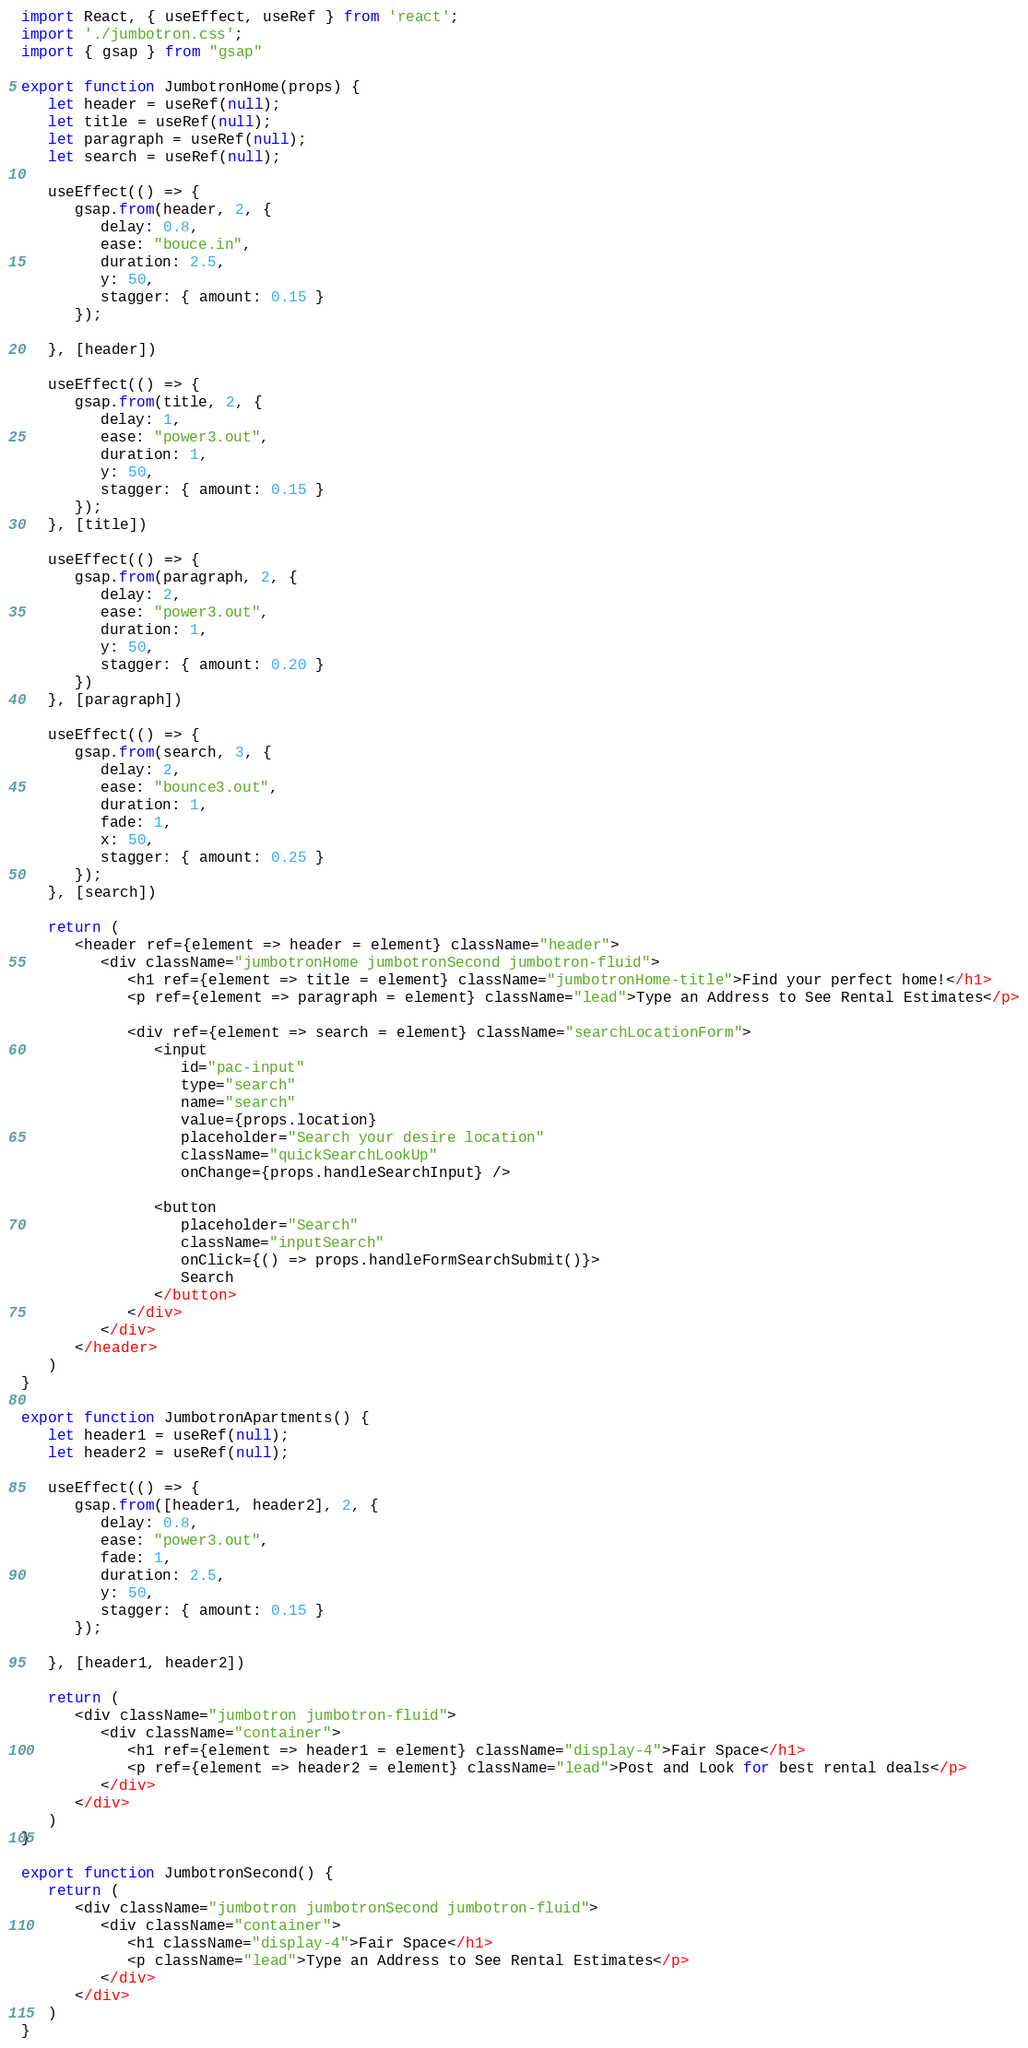<code> <loc_0><loc_0><loc_500><loc_500><_JavaScript_>import React, { useEffect, useRef } from 'react';
import './jumbotron.css';
import { gsap } from "gsap"

export function JumbotronHome(props) {
   let header = useRef(null);
   let title = useRef(null);
   let paragraph = useRef(null);
   let search = useRef(null);

   useEffect(() => {
      gsap.from(header, 2, {
         delay: 0.8,
         ease: "bouce.in",
         duration: 2.5,
         y: 50,
         stagger: { amount: 0.15 }
      });

   }, [header])

   useEffect(() => {
      gsap.from(title, 2, {
         delay: 1,
         ease: "power3.out",
         duration: 1,
         y: 50,
         stagger: { amount: 0.15 }
      });
   }, [title])

   useEffect(() => {
      gsap.from(paragraph, 2, {
         delay: 2,
         ease: "power3.out",
         duration: 1,
         y: 50,
         stagger: { amount: 0.20 }
      })
   }, [paragraph])

   useEffect(() => {
      gsap.from(search, 3, {
         delay: 2,
         ease: "bounce3.out",
         duration: 1,
         fade: 1,
         x: 50,
         stagger: { amount: 0.25 }
      });
   }, [search])

   return (
      <header ref={element => header = element} className="header">
         <div className="jumbotronHome jumbotronSecond jumbotron-fluid">
            <h1 ref={element => title = element} className="jumbotronHome-title">Find your perfect home!</h1>
            <p ref={element => paragraph = element} className="lead">Type an Address to See Rental Estimates</p>

            <div ref={element => search = element} className="searchLocationForm">
               <input
                  id="pac-input"
                  type="search"
                  name="search"
                  value={props.location}
                  placeholder="Search your desire location"
                  className="quickSearchLookUp"
                  onChange={props.handleSearchInput} />

               <button
                  placeholder="Search"
                  className="inputSearch"
                  onClick={() => props.handleFormSearchSubmit()}>
                  Search
               </button>
            </div>
         </div>
      </header>
   )
}

export function JumbotronApartments() {
   let header1 = useRef(null);
   let header2 = useRef(null);

   useEffect(() => {
      gsap.from([header1, header2], 2, {
         delay: 0.8,
         ease: "power3.out",
         fade: 1,
         duration: 2.5,
         y: 50,
         stagger: { amount: 0.15 }
      });

   }, [header1, header2])

   return (
      <div className="jumbotron jumbotron-fluid">
         <div className="container">
            <h1 ref={element => header1 = element} className="display-4">Fair Space</h1>
            <p ref={element => header2 = element} className="lead">Post and Look for best rental deals</p>
         </div>
      </div>
   )
}

export function JumbotronSecond() {
   return (
      <div className="jumbotron jumbotronSecond jumbotron-fluid">
         <div className="container">
            <h1 className="display-4">Fair Space</h1>
            <p className="lead">Type an Address to See Rental Estimates</p>
         </div>
      </div>
   )
}</code> 